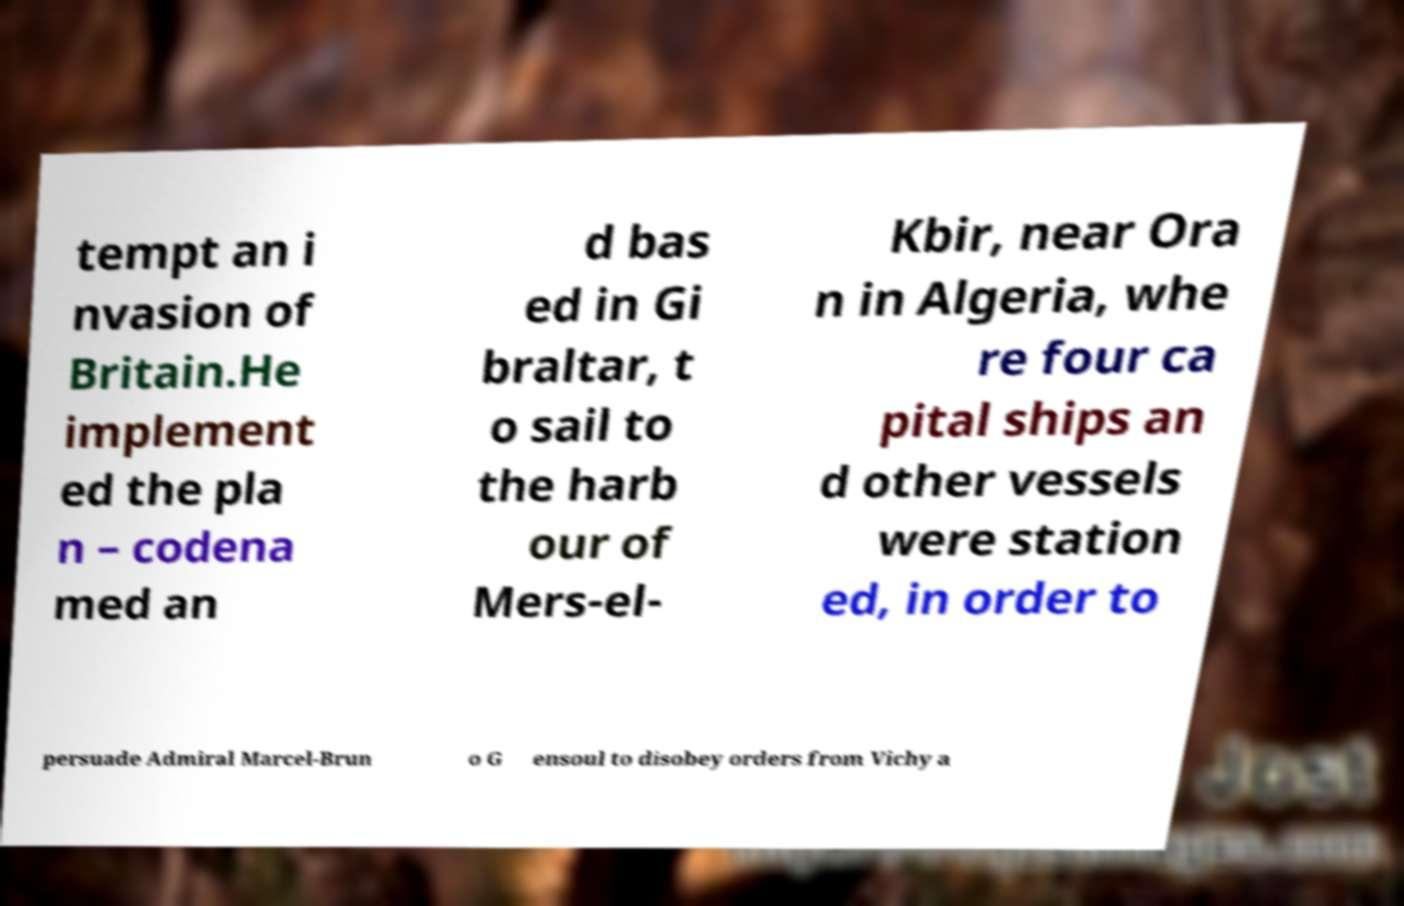What messages or text are displayed in this image? I need them in a readable, typed format. tempt an i nvasion of Britain.He implement ed the pla n – codena med an d bas ed in Gi braltar, t o sail to the harb our of Mers-el- Kbir, near Ora n in Algeria, whe re four ca pital ships an d other vessels were station ed, in order to persuade Admiral Marcel-Brun o G ensoul to disobey orders from Vichy a 